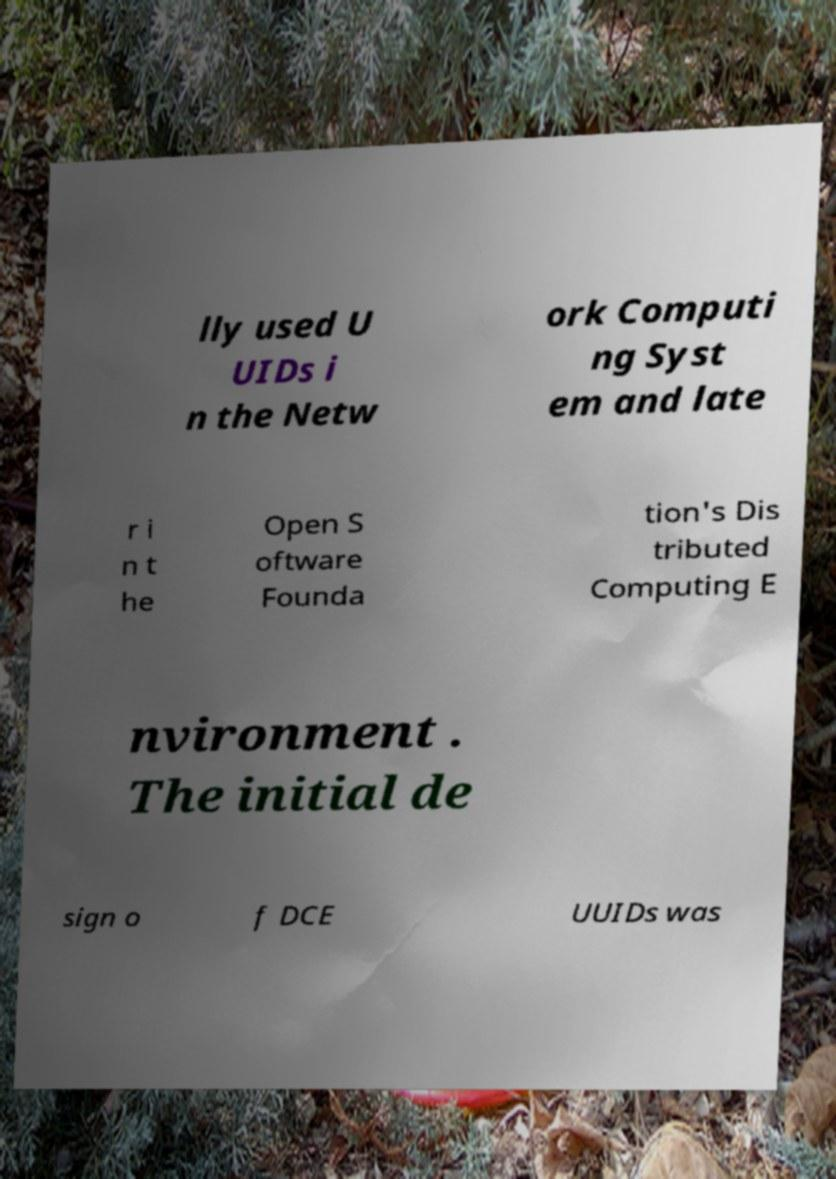Can you read and provide the text displayed in the image?This photo seems to have some interesting text. Can you extract and type it out for me? lly used U UIDs i n the Netw ork Computi ng Syst em and late r i n t he Open S oftware Founda tion's Dis tributed Computing E nvironment . The initial de sign o f DCE UUIDs was 